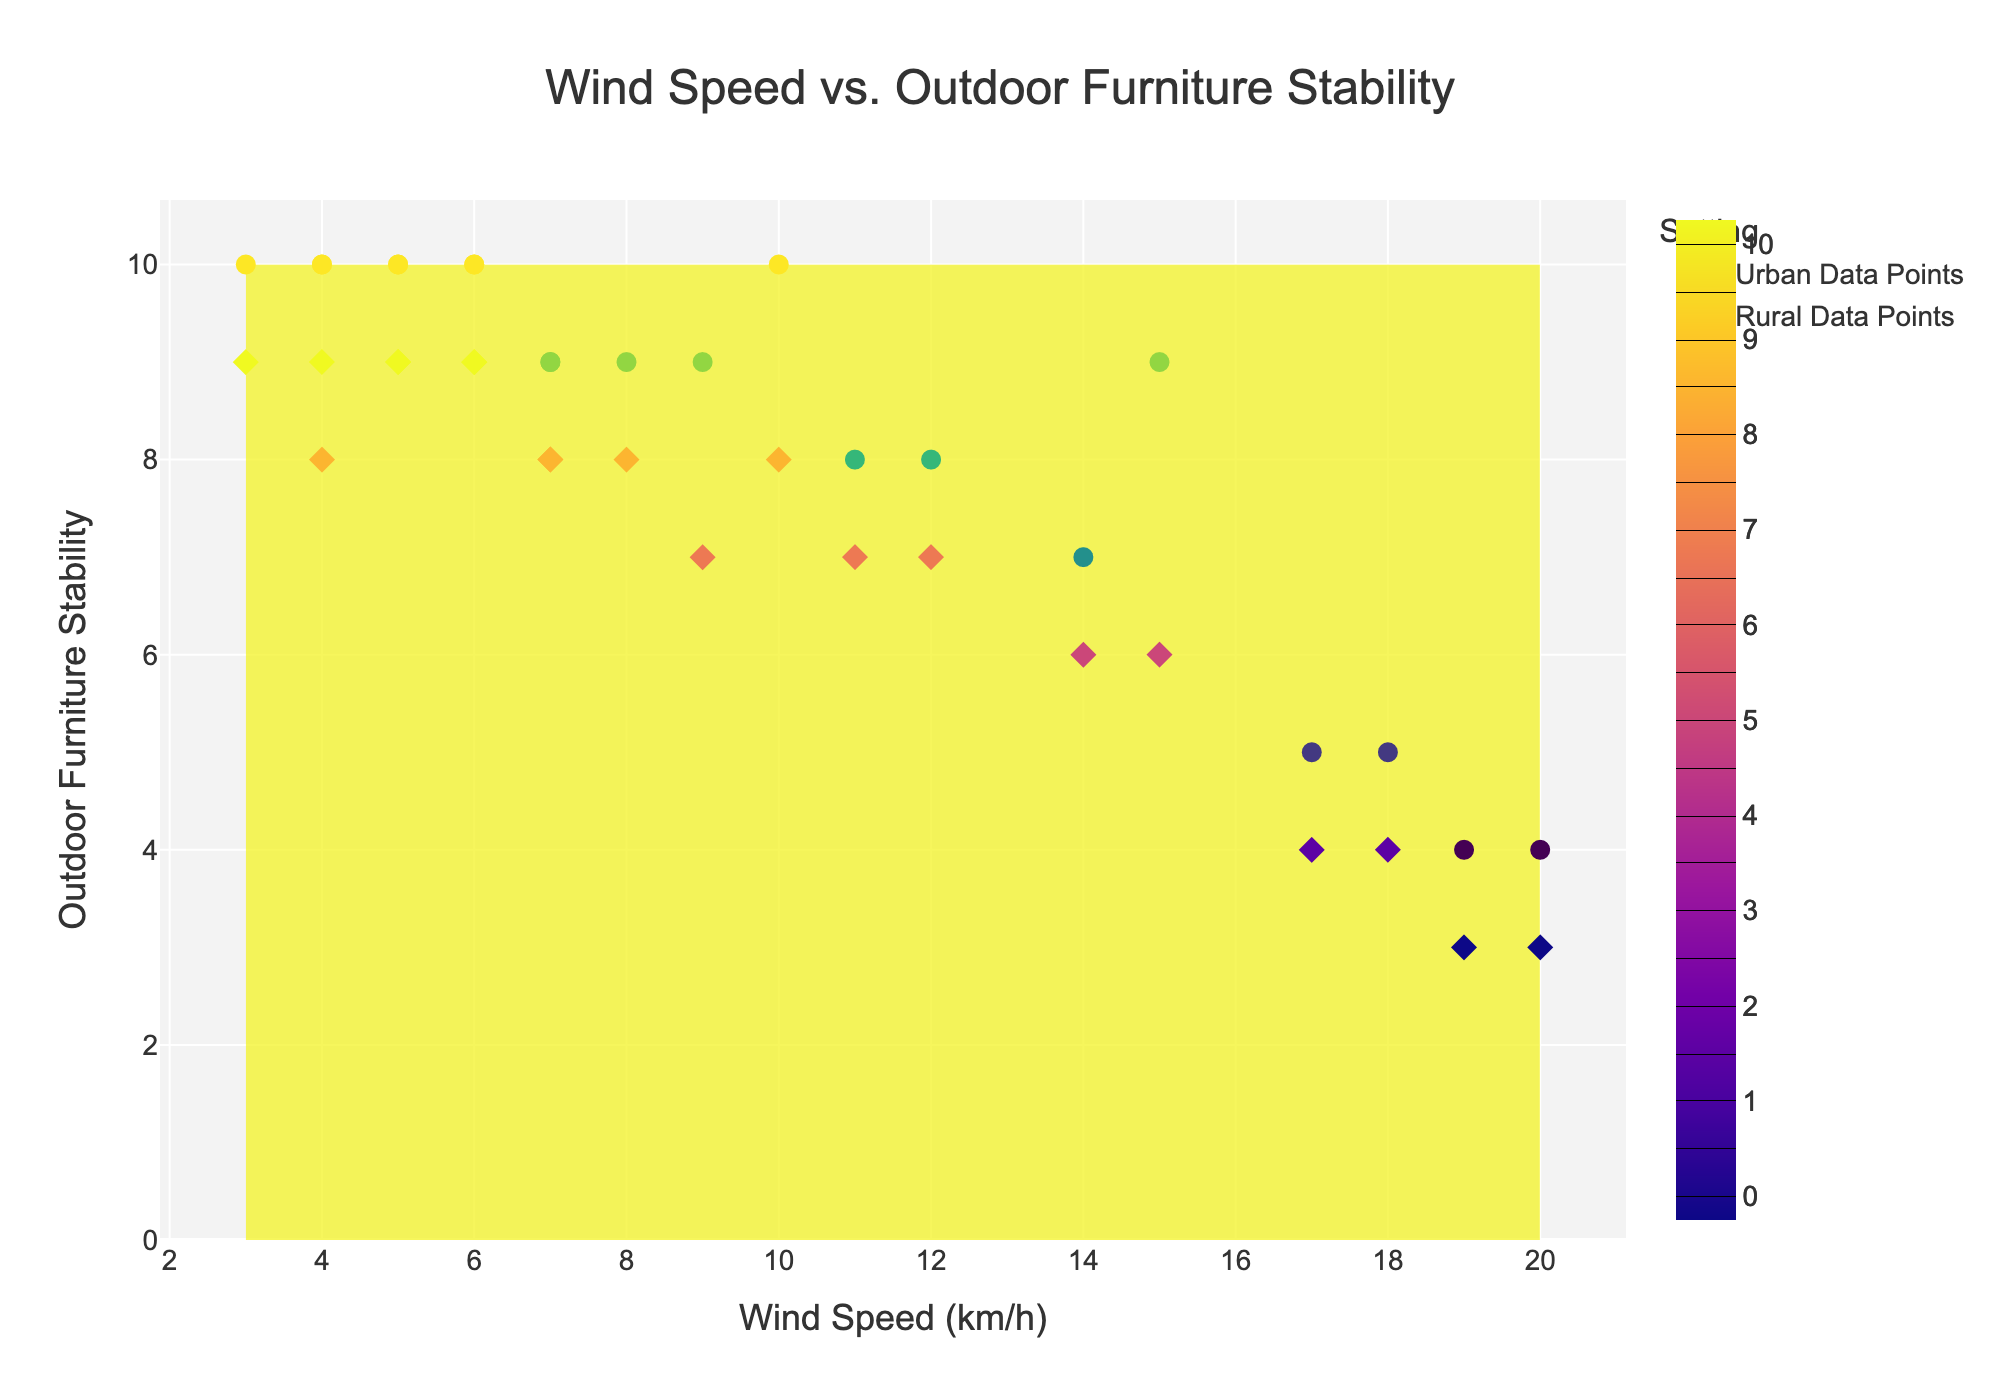what is the title of the figure? The title is usually placed at the top of the figure and is clearly labeled.
Answer: Wind Speed vs. Outdoor Furniture Stability How many different settings does the plot compare? The plot legend and the contour labels show the different settings compared.
Answer: Two (urban and rural) Which wind speed value corresponds to the highest outdoor furniture stability in urban areas? Look for the highest contour values and note their corresponding wind speed on the x-axis.
Answer: 10 km/h What is the wind speed associated with the lowest outdoor furniture stability in rural settings? Look at the contour with the lowest values and find the corresponding wind speed on the x-axis.
Answer: 20 km/h How does outdoor furniture stability change as wind speed increases in urban areas compared to rural areas? Observe the contour lines' color gradient and points' distribution from low to high wind speeds in both settings.
Answer: Stability decreases faster in urban areas than in rural areas Are there any wind speeds where outdoor furniture stability is the same for both urban and rural settings? Identify points where the contours of urban and rural settings intersect at similar stability levels.
Answer: Yes, around 7 km/h What range of wind speeds has the highest concentration of high stability for rural outdoor furniture arrangement? Observe the densest area of high stability values within the rural contours.
Answer: 3-6 km/h Is there any overlapping contour area in the stability levels of urban and rural settings? Look for areas where the contour lines from both settings overlap or are close to each other.
Answer: Yes, between 5 and 7 km/h Which setting shows a wider range of wind speed values with consistent high stability? Compare the width of stability range across wind speeds for the two settings using contour lines.
Answer: Rural settings Which location seems to be the most stable for outdoor furniture in urban settings? Refer to the highest stability points marked by scatter data for urban areas.
Answer: Tribeca 